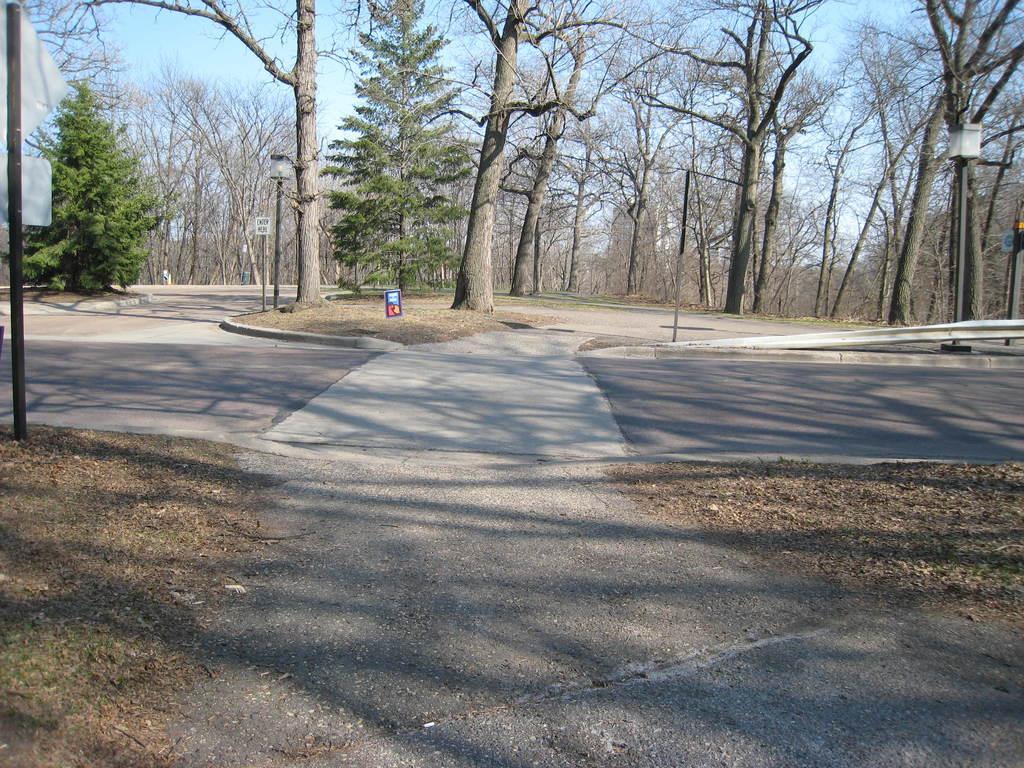Describe this image in one or two sentences. In this image I can see a road, there are some trees and the sky visible beside the road, there is a street light pole visible on the right side. 